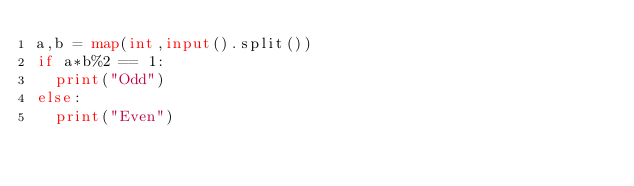<code> <loc_0><loc_0><loc_500><loc_500><_Python_>a,b = map(int,input().split())
if a*b%2 == 1:
  print("Odd")
else:
  print("Even")</code> 